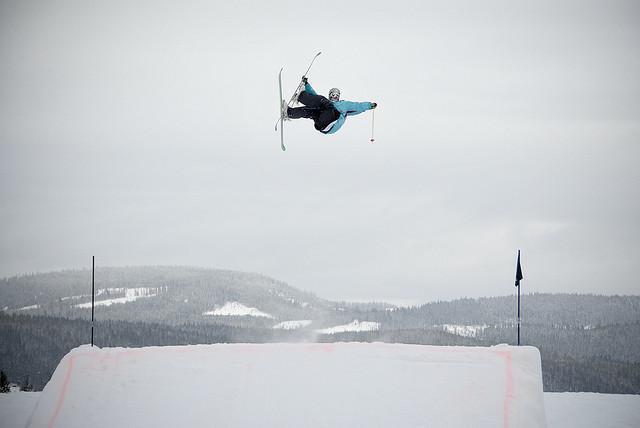How many black cars are there?
Give a very brief answer. 0. 